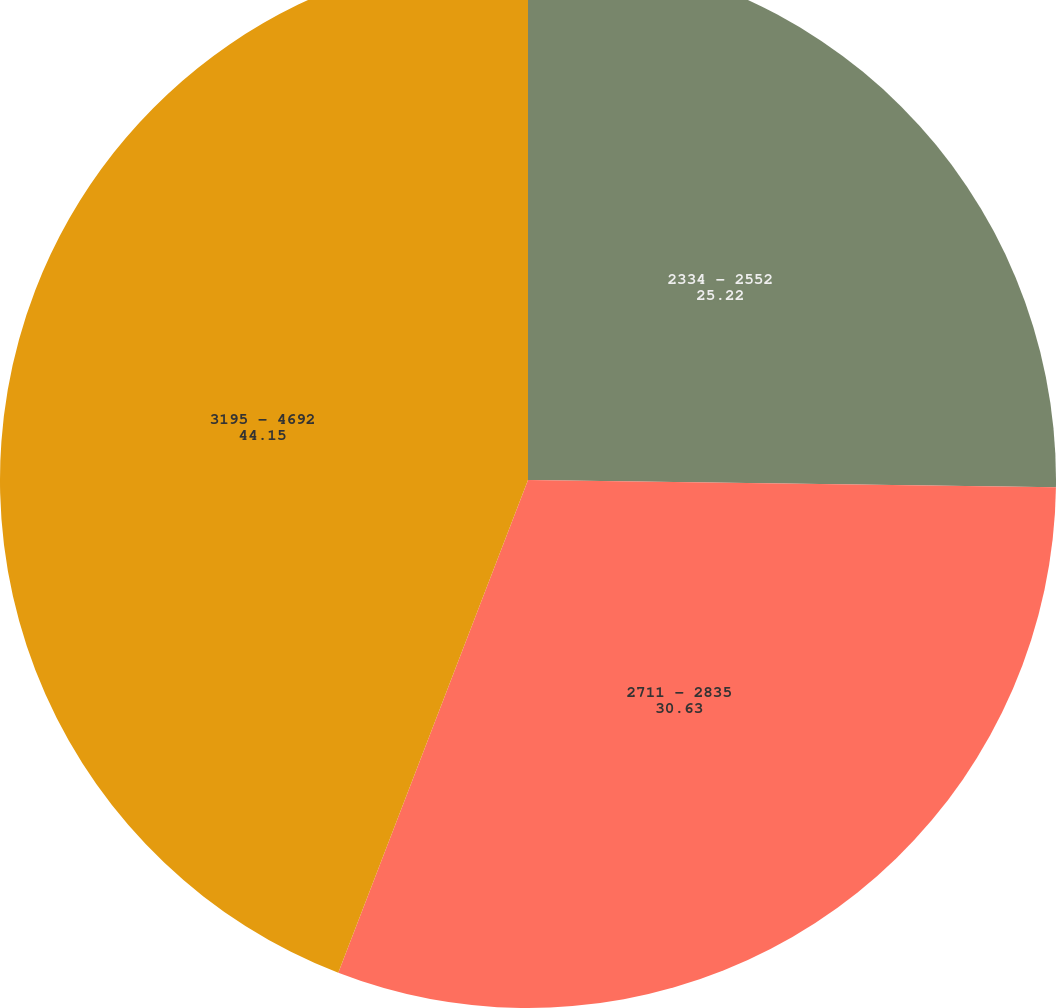Convert chart. <chart><loc_0><loc_0><loc_500><loc_500><pie_chart><fcel>2334 - 2552<fcel>2711 - 2835<fcel>3195 - 4692<nl><fcel>25.22%<fcel>30.63%<fcel>44.15%<nl></chart> 